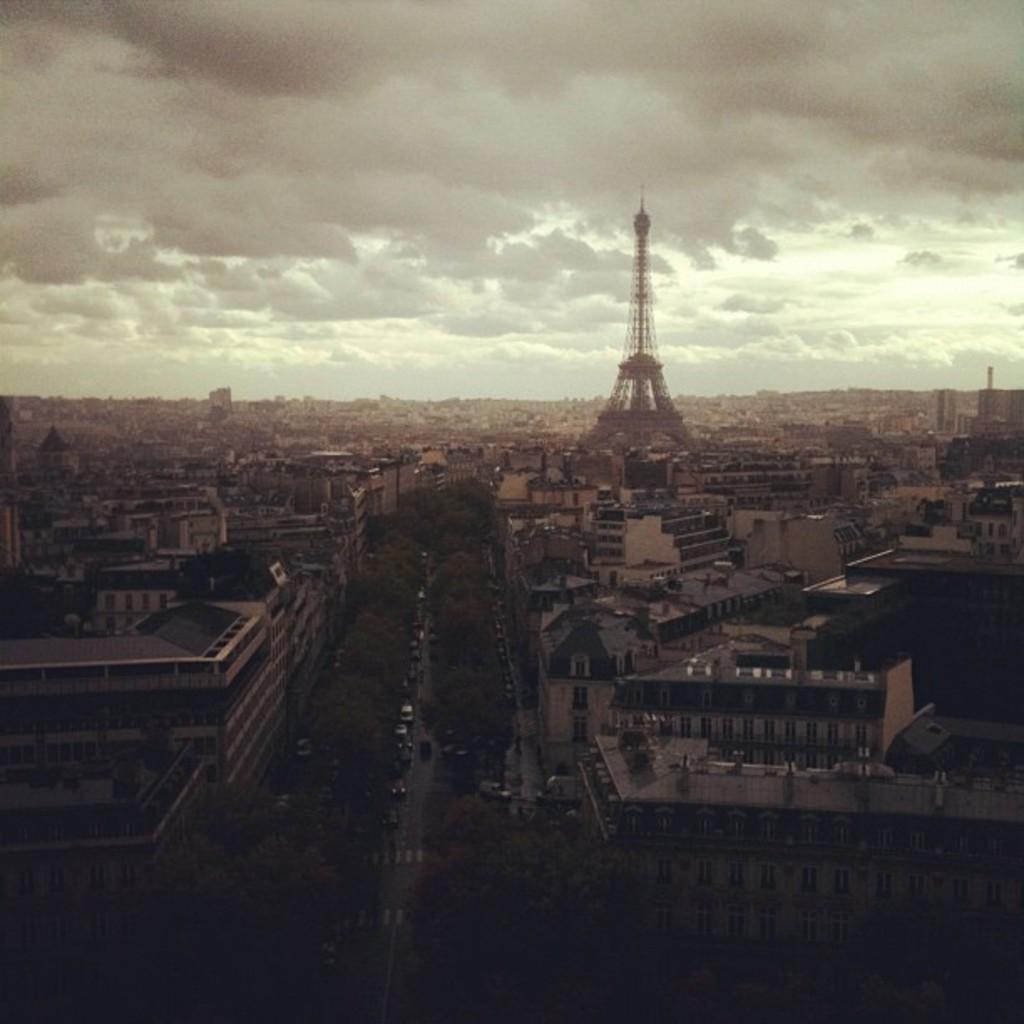Please provide a concise description of this image. This picture is clicked outside the city. In the foreground we can see the vehicles, trees, houses, buildings and tower. In the background there is a sky which is full of clouds. 